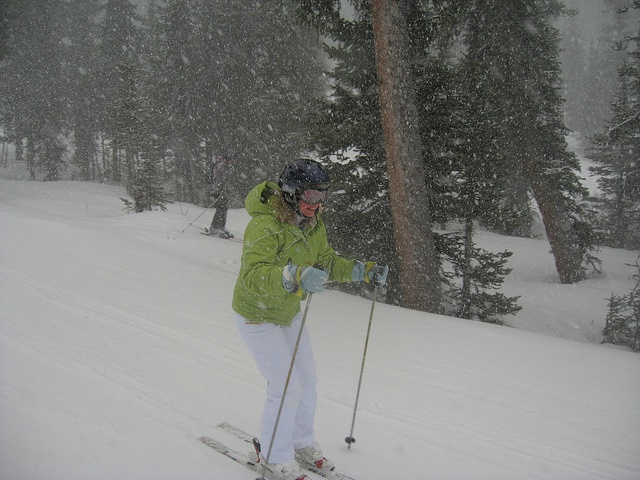Describe the objects in this image and their specific colors. I can see people in black, darkgray, gray, darkgreen, and olive tones, people in black and gray tones, and skis in black, darkgray, and gray tones in this image. 